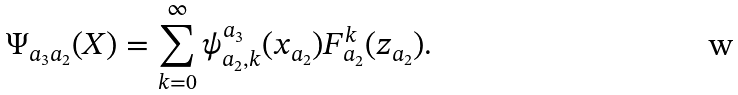<formula> <loc_0><loc_0><loc_500><loc_500>\Psi _ { { a _ { 3 } } { a _ { 2 } } } ( { X } ) = \sum _ { k = 0 } ^ { \infty } \psi _ { { a _ { 2 } } , k } ^ { a _ { 3 } } ( { x } _ { a _ { 2 } } ) F _ { a _ { 2 } } ^ { k } ( { z } _ { a _ { 2 } } ) .</formula> 